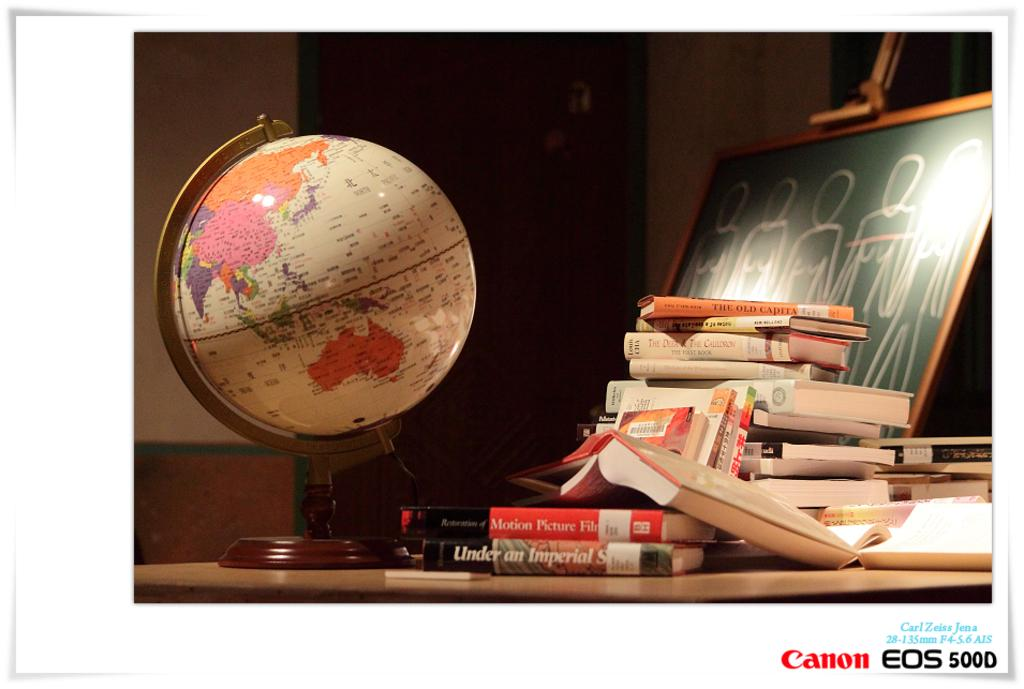What type of image is being described? The image is a poster. What is the main subject of the poster? There is a globe in the poster. What other items can be seen in the poster? There are many books and a green board with drawings in the poster. What can be seen in the background of the poster? There is a wall and a door in the background of the poster. What type of calculator is being used on the stove in the image? There is no calculator or stove present in the image. What is the level of interest in the poster? The level of interest cannot be determined from the image, as it is a description of the objects and subjects present, not an evaluation of their appeal. 